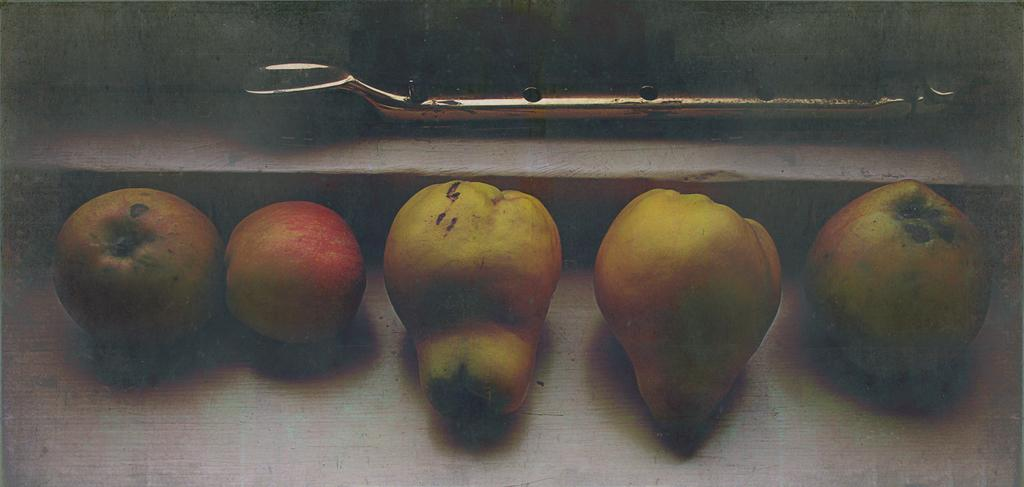What type of fruits are in the foreground of the image? There is a pear fruit and an apple in the foreground of the image. Where are the fruits placed in the image? The fruits are placed on a surface in the image. What can be seen in the background of the image? There is a window handle visible in the background of the image. What type of nail is being used to hold the dinner plate in the image? There is no nail or dinner plate present in the image; it features a pear fruit and an apple on a surface. 